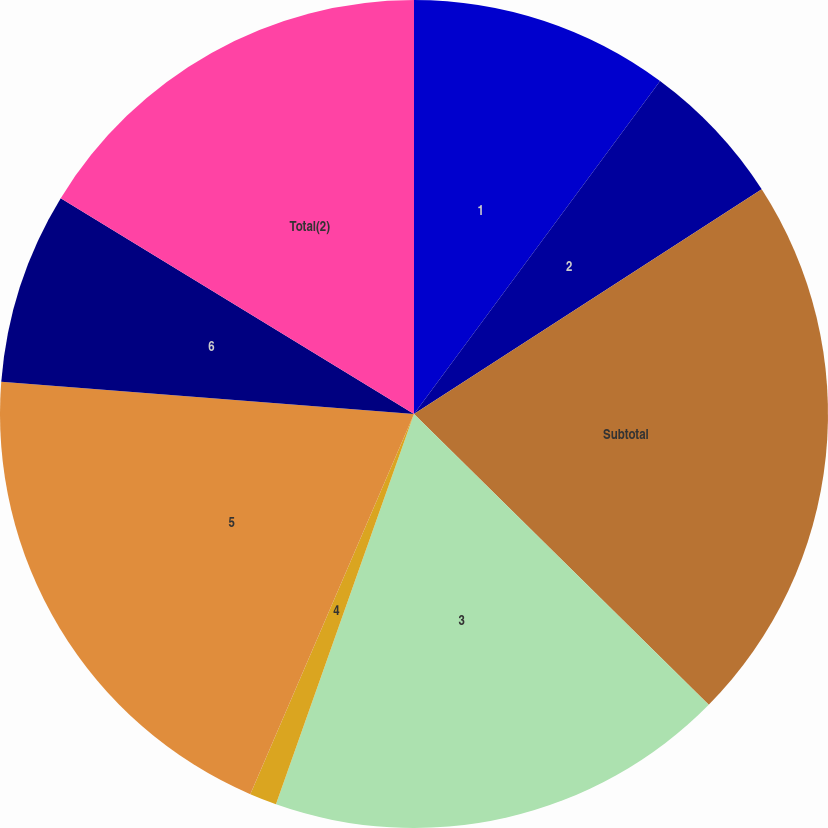Convert chart. <chart><loc_0><loc_0><loc_500><loc_500><pie_chart><fcel>1<fcel>2<fcel>Subtotal<fcel>3<fcel>4<fcel>5<fcel>6<fcel>Total(2)<nl><fcel>10.13%<fcel>5.74%<fcel>21.52%<fcel>18.02%<fcel>1.06%<fcel>19.77%<fcel>7.49%<fcel>16.27%<nl></chart> 